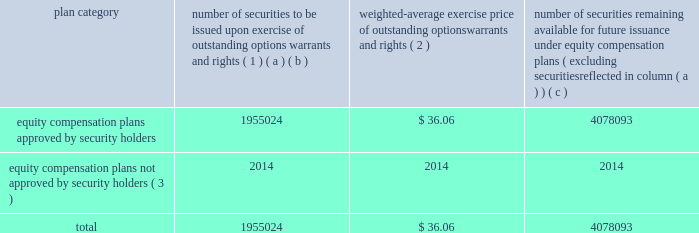Equity compensation plan information the table presents the equity securities available for issuance under our equity compensation plans as of december 31 , 2014 .
Equity compensation plan information plan category number of securities to be issued upon exercise of outstanding options , warrants and rights ( 1 ) weighted-average exercise price of outstanding options , warrants and rights ( 2 ) number of securities remaining available for future issuance under equity compensation plans ( excluding securities reflected in column ( a ) ) ( a ) ( b ) ( c ) equity compensation plans approved by security holders 1955024 $ 36.06 4078093 equity compensation plans not approved by security holders ( 3 ) 2014 2014 2014 .
( 1 ) includes grants made under the huntington ingalls industries , inc .
2012 long-term incentive stock plan ( the "2012 plan" ) , which was approved by our stockholders on may 2 , 2012 , and the huntington ingalls industries , inc .
2011 long-term incentive stock plan ( the "2011 plan" ) , which was approved by the sole stockholder of hii prior to its spin-off from northrop grumman corporation .
Of these shares , 644321 were subject to stock options , 539742 were subject to outstanding restricted performance stock rights , and 63022 were stock rights granted under the 2011 plan .
In addition , this number includes 33571 stock rights , 11046 restricted stock rights and 663322 restricted performance stock rights granted under the 2012 plan , assuming target performance achievement .
( 2 ) this is the weighted average exercise price of the 644321 outstanding stock options only .
( 3 ) there are no awards made under plans not approved by security holders .
Item 13 .
Certain relationships and related transactions , and director independence information as to certain relationships and related transactions and director independence will be incorporated herein by reference to the proxy statement for our 2015 annual meeting of stockholders to be filed within 120 days after the end of the company 2019s fiscal year .
Item 14 .
Principal accountant fees and services information as to principal accountant fees and services will be incorporated herein by reference to the proxy statement for our 2015 annual meeting of stockholders to be filed within 120 days after the end of the company 2019s fiscal year .
This proof is printed at 96% ( 96 % ) of original size this line represents final trim and will not print .
What is the combined equity compensation plans approved by security holders? 
Rationale: the combined amount is the sum
Computations: (1955024 + 4078093)
Answer: 6033117.0. 